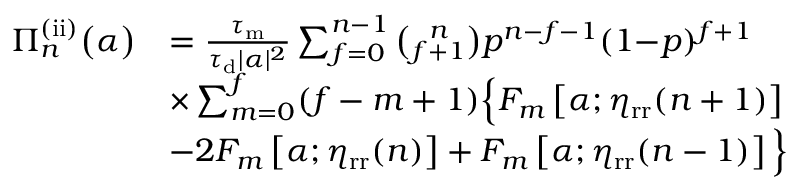<formula> <loc_0><loc_0><loc_500><loc_500>\begin{array} { r l } { \Pi _ { n } ^ { ( i i ) } \left ( \alpha \right ) } & { = \frac { \tau _ { m } } { \tau _ { d } | \alpha | ^ { 2 } } \sum _ { f = 0 } ^ { n - 1 } \binom { n } { f + 1 } p ^ { n - f - 1 } ( 1 { - } p ) ^ { f + 1 } } \\ & { \times \sum _ { m = 0 } ^ { f } ( f - m + 1 ) \left \{ F _ { m } \left [ \alpha ; \eta _ { r r } ( n + 1 ) \right ] } \\ & { - 2 F _ { m } \left [ \alpha ; \eta _ { r r } ( n ) \right ] + F _ { m } \left [ \alpha ; \eta _ { r r } ( n - 1 ) \right ] \right \} } \end{array}</formula> 